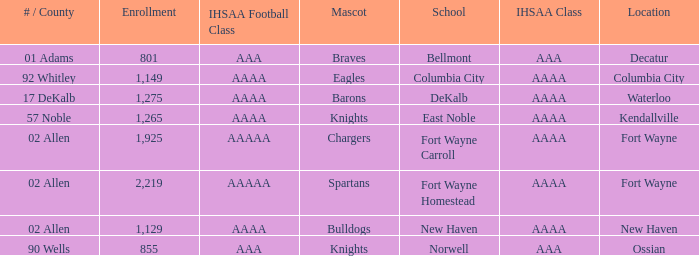What's the IHSAA Football Class in Decatur with an AAA IHSAA class? AAA. 